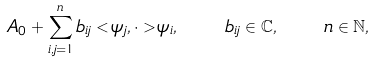<formula> <loc_0><loc_0><loc_500><loc_500>A _ { 0 } + \sum _ { i , j = 1 } ^ { n } { b } _ { i j } < \psi _ { j } , \cdot > \psi _ { i } , \quad b _ { i j } \in \mathbb { C } , \quad n \in \mathbb { N } ,</formula> 